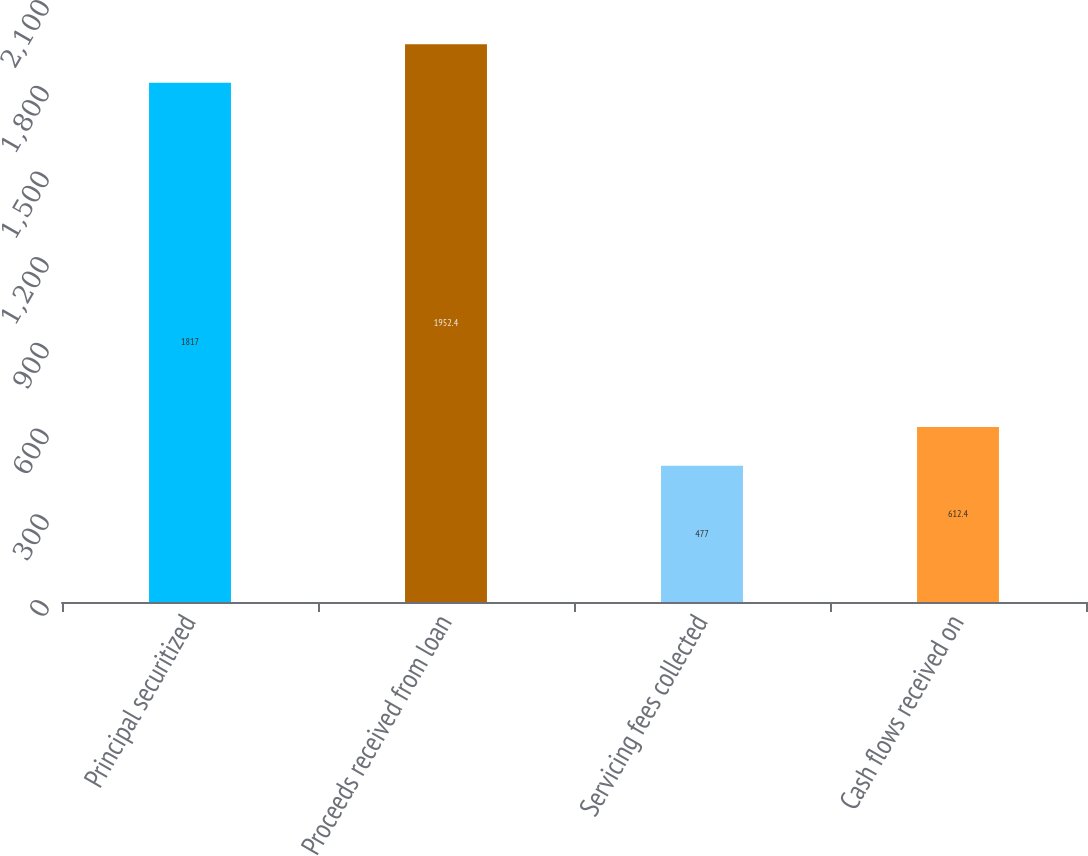<chart> <loc_0><loc_0><loc_500><loc_500><bar_chart><fcel>Principal securitized<fcel>Proceeds received from loan<fcel>Servicing fees collected<fcel>Cash flows received on<nl><fcel>1817<fcel>1952.4<fcel>477<fcel>612.4<nl></chart> 